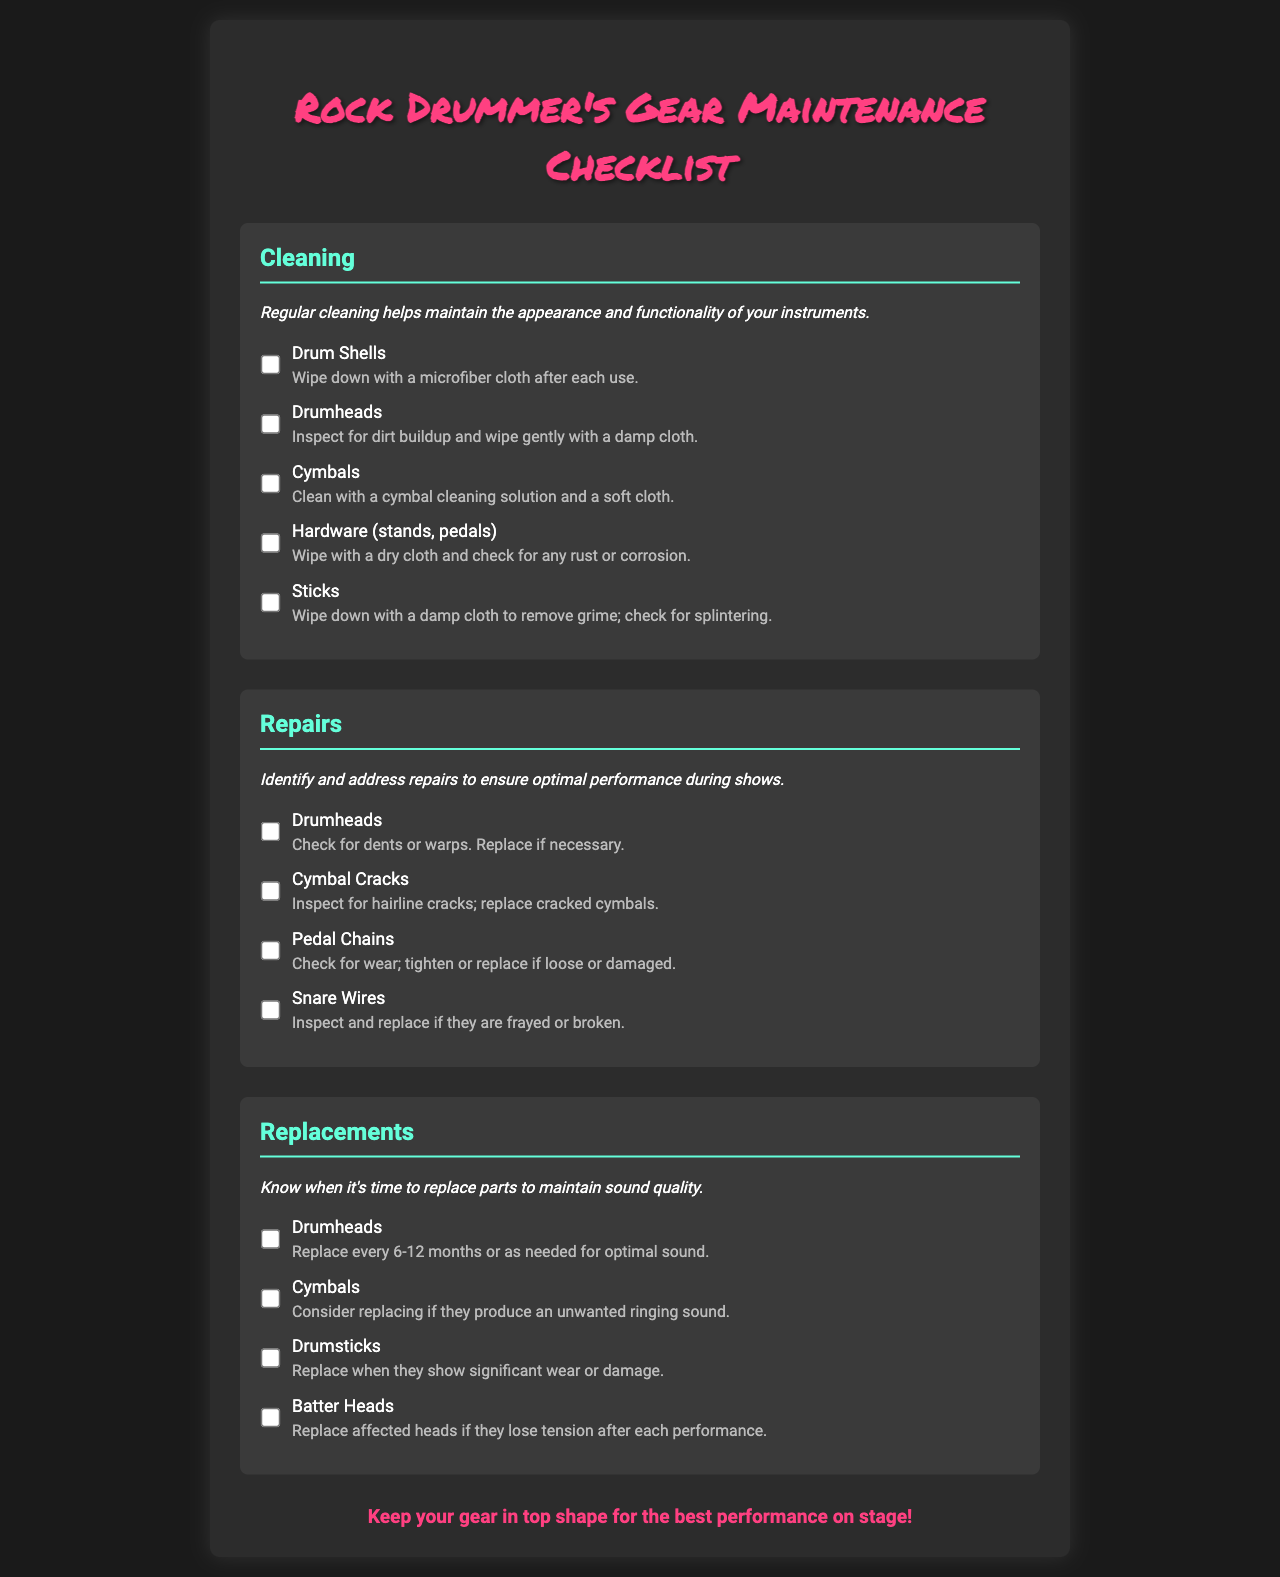What is the title of the checklist? The title is displayed prominently at the top of the document, indicating its purpose for drummers.
Answer: Rock Drummer's Gear Maintenance Checklist How many sections are in the form? The document is divided into three main sections: Cleaning, Repairs, and Replacements.
Answer: 3 What should you use to clean the cymbals? This information can be found in the Cleaning section under Cymbals.
Answer: Cymbal cleaning solution and a soft cloth When should drumheads typically be replaced? The replacement frequency is mentioned in the Replacements section under Drumheads.
Answer: Every 6-12 months What is inspected for dents or warps? This question relates to the Repairs section and asks for a specific part of the gear.
Answer: Drumheads Which item should be checked for wear in the Repairs section? The context refers to a specific part mentioned that requires maintenance.
Answer: Pedal Chains What color is the heading for the Repairs section? The color of the heading is specified in the styles defined for the document.
Answer: #64ffda What happens if a cymbal produces an unwanted ringing sound? This relates to the guidance on replacements found in the Replacements section regarding cymbals.
Answer: Consider replacing it 